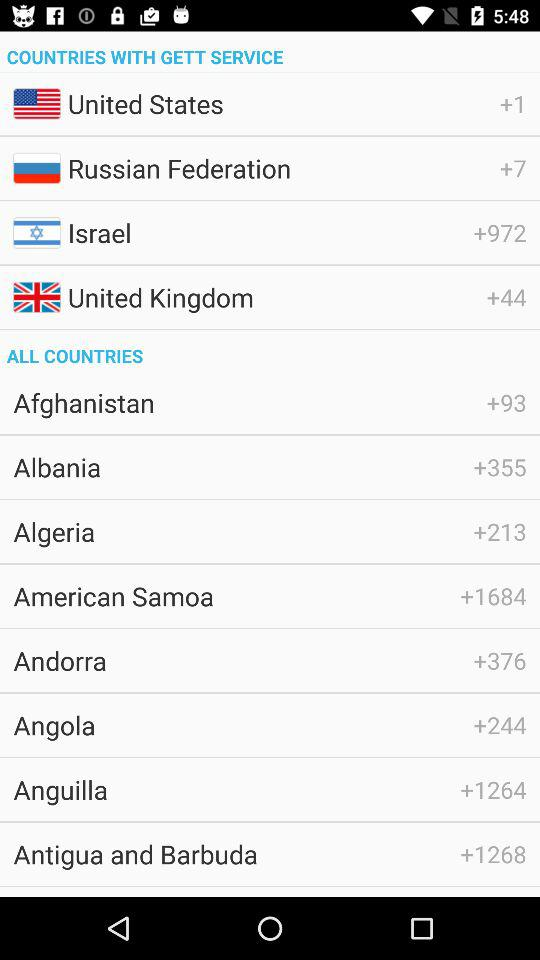What are the names of the countries with "Gett" service? The names of the countries are the United States, the Russian Federation, Israel and the United Kingdom. 